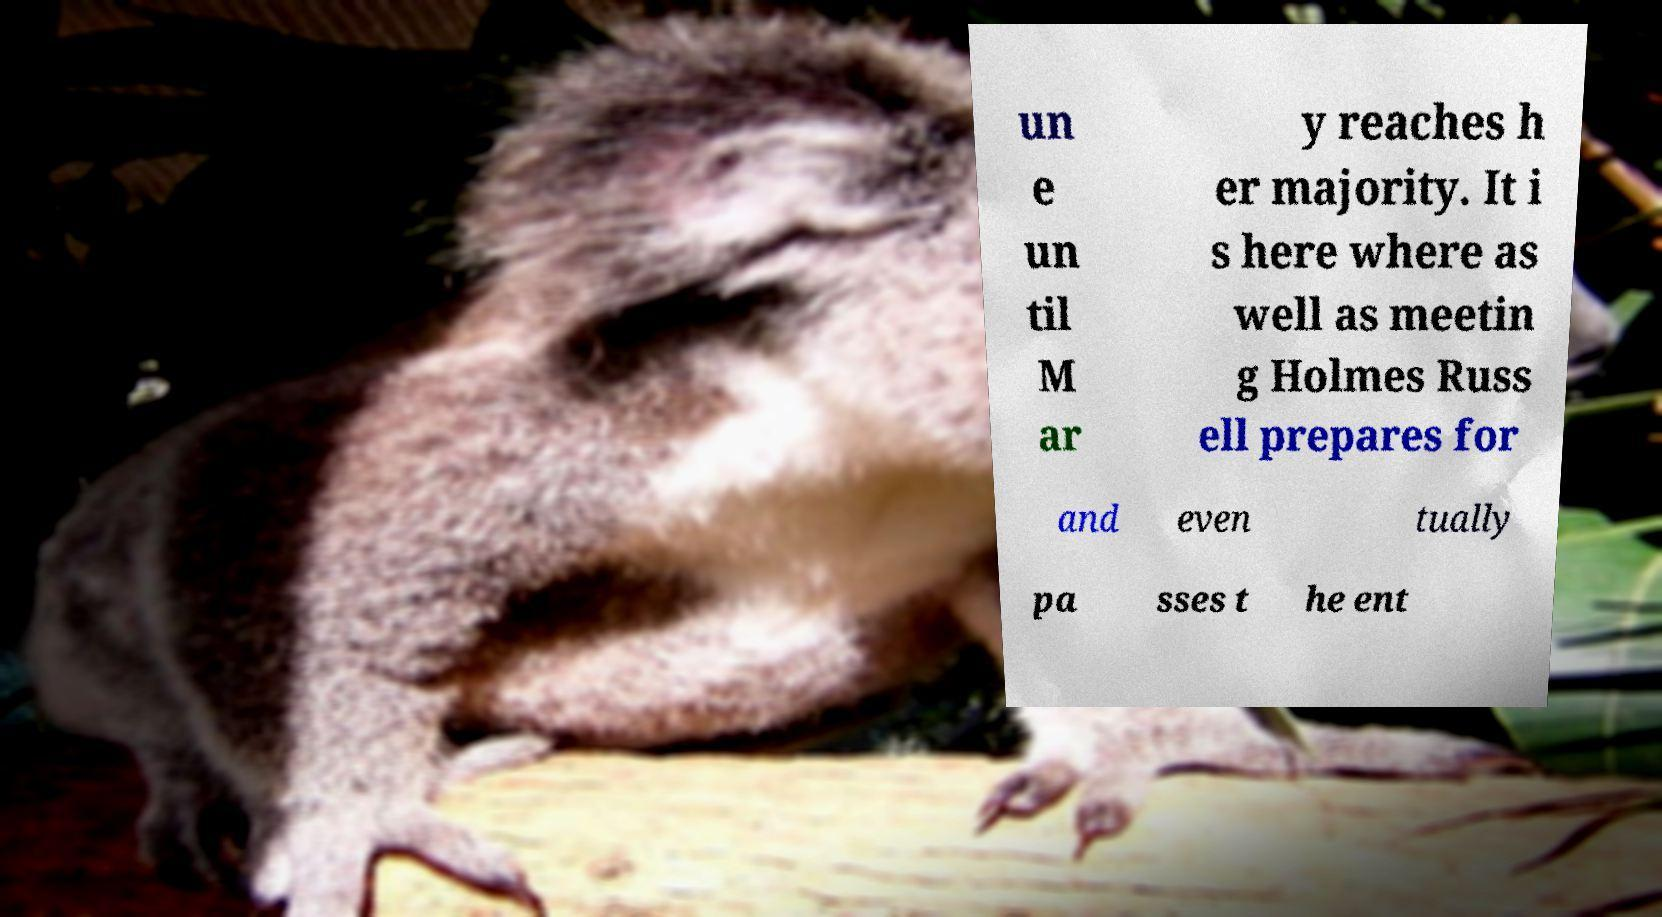There's text embedded in this image that I need extracted. Can you transcribe it verbatim? un e un til M ar y reaches h er majority. It i s here where as well as meetin g Holmes Russ ell prepares for and even tually pa sses t he ent 